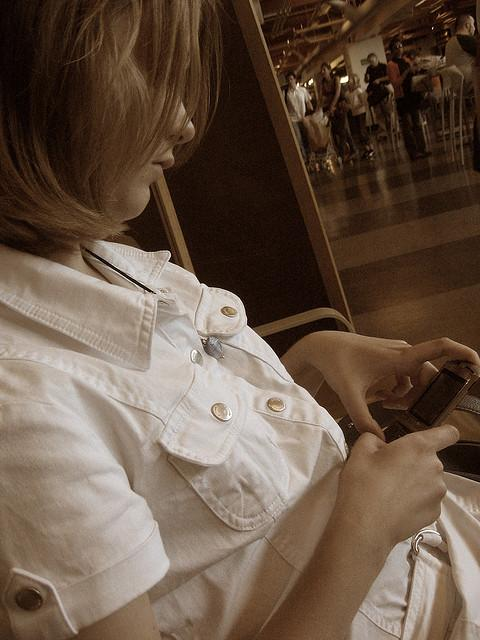What are the people lining up for?

Choices:
A) boarding bus
B) boarding plane
C) buying tickets
D) buying food buying food 